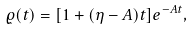Convert formula to latex. <formula><loc_0><loc_0><loc_500><loc_500>\varrho ( t ) = [ 1 + ( \eta - A ) t ] e ^ { - A t } ,</formula> 